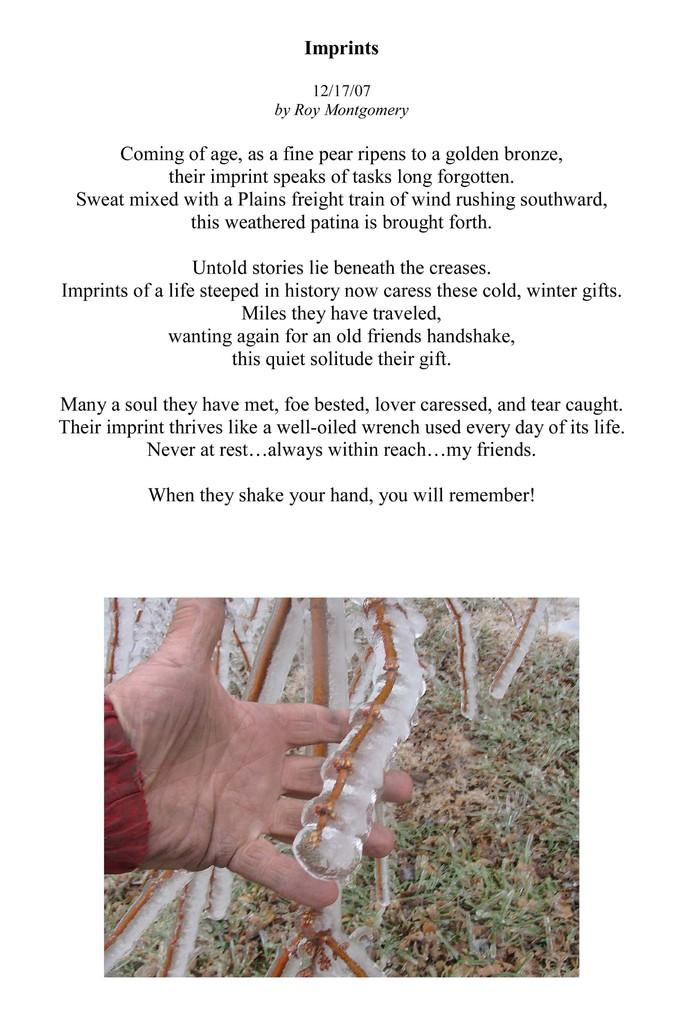What is the main subject of the image? There is a person in the image. What is the person holding in the image? The person is holding a stick. What type of environment is depicted in the image? There is grassland in the image. What is written or depicted above the grassland? There is text above the grassland. What type of coal can be seen bursting in the image? There is no coal or bursting action present in the image. 